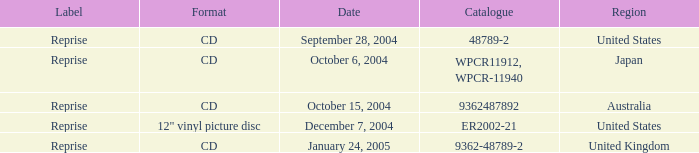Name the catalogue for australia 9362487892.0. Can you parse all the data within this table? {'header': ['Label', 'Format', 'Date', 'Catalogue', 'Region'], 'rows': [['Reprise', 'CD', 'September 28, 2004', '48789-2', 'United States'], ['Reprise', 'CD', 'October 6, 2004', 'WPCR11912, WPCR-11940', 'Japan'], ['Reprise', 'CD', 'October 15, 2004', '9362487892', 'Australia'], ['Reprise', '12" vinyl picture disc', 'December 7, 2004', 'ER2002-21', 'United States'], ['Reprise', 'CD', 'January 24, 2005', '9362-48789-2', 'United Kingdom']]} 